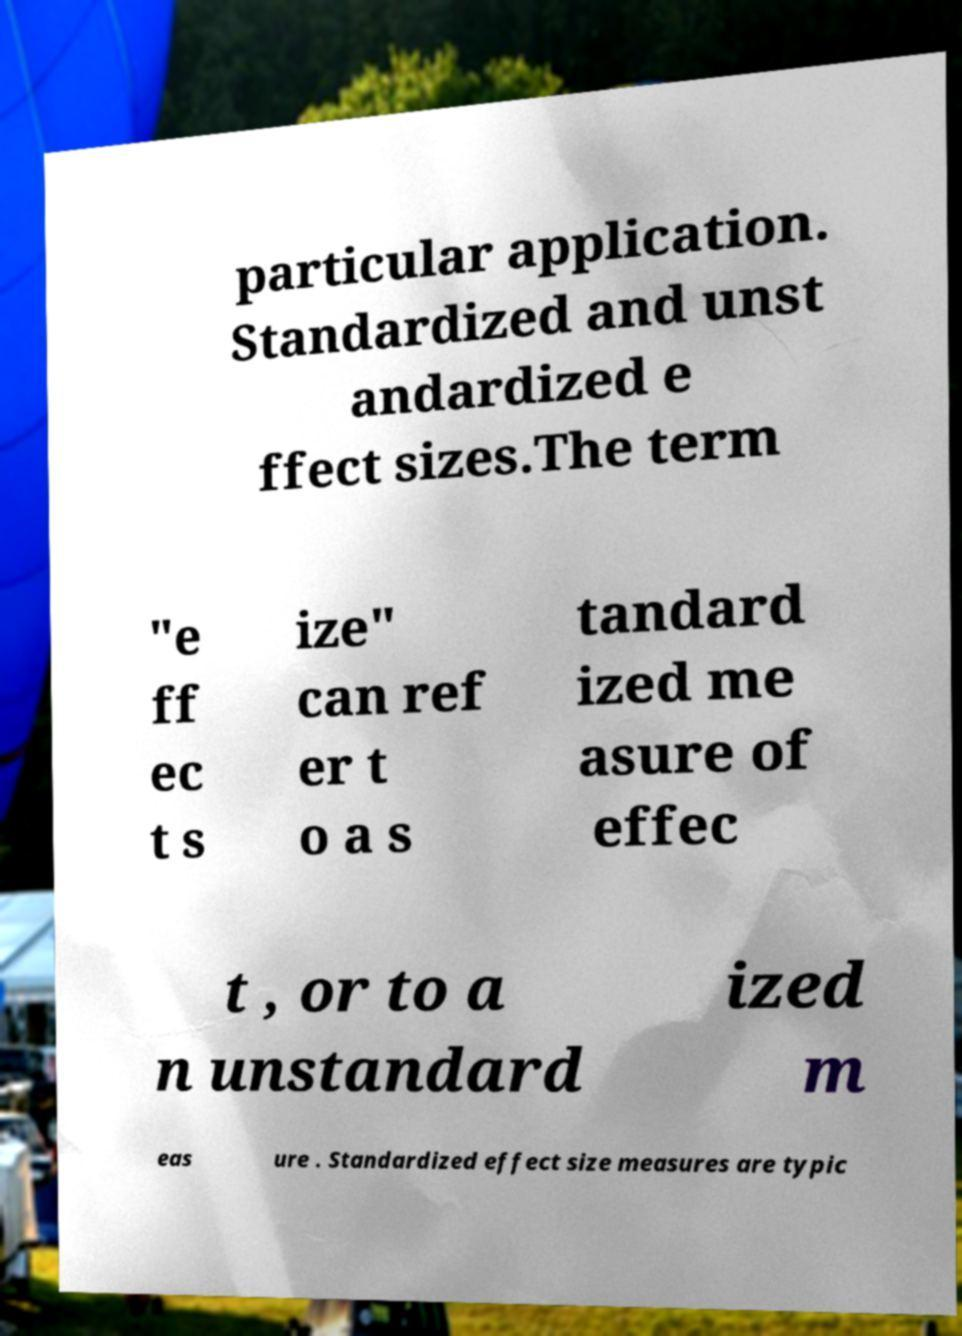Can you read and provide the text displayed in the image?This photo seems to have some interesting text. Can you extract and type it out for me? particular application. Standardized and unst andardized e ffect sizes.The term "e ff ec t s ize" can ref er t o a s tandard ized me asure of effec t , or to a n unstandard ized m eas ure . Standardized effect size measures are typic 